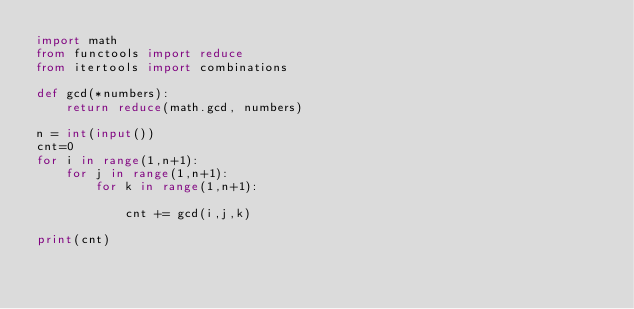<code> <loc_0><loc_0><loc_500><loc_500><_Python_>import math
from functools import reduce
from itertools import combinations

def gcd(*numbers):
    return reduce(math.gcd, numbers)

n = int(input())
cnt=0
for i in range(1,n+1):
    for j in range(1,n+1):
        for k in range(1,n+1):

            cnt += gcd(i,j,k)

print(cnt)</code> 